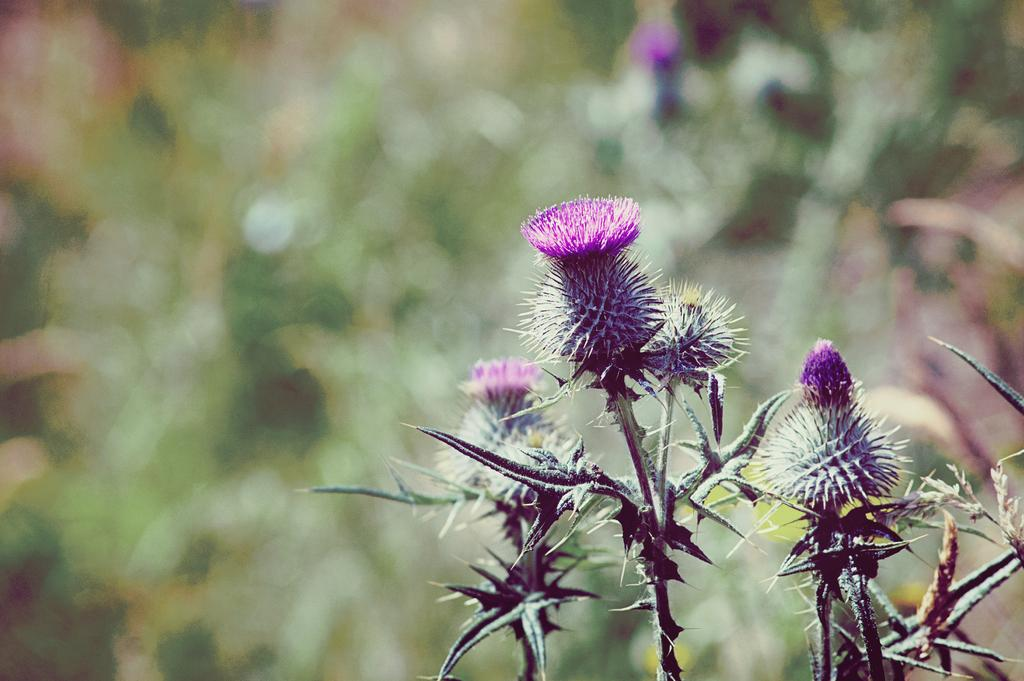What type of plants are featured in the image? There are plants named as spear thistle in the image. What color are the flowers on the plants? The flowers on the plants are violet. Can you describe the background of the image? The background of the image appears blurry. How does the paste affect the plants in the image? There is no mention of paste in the image, so it cannot affect the plants. 